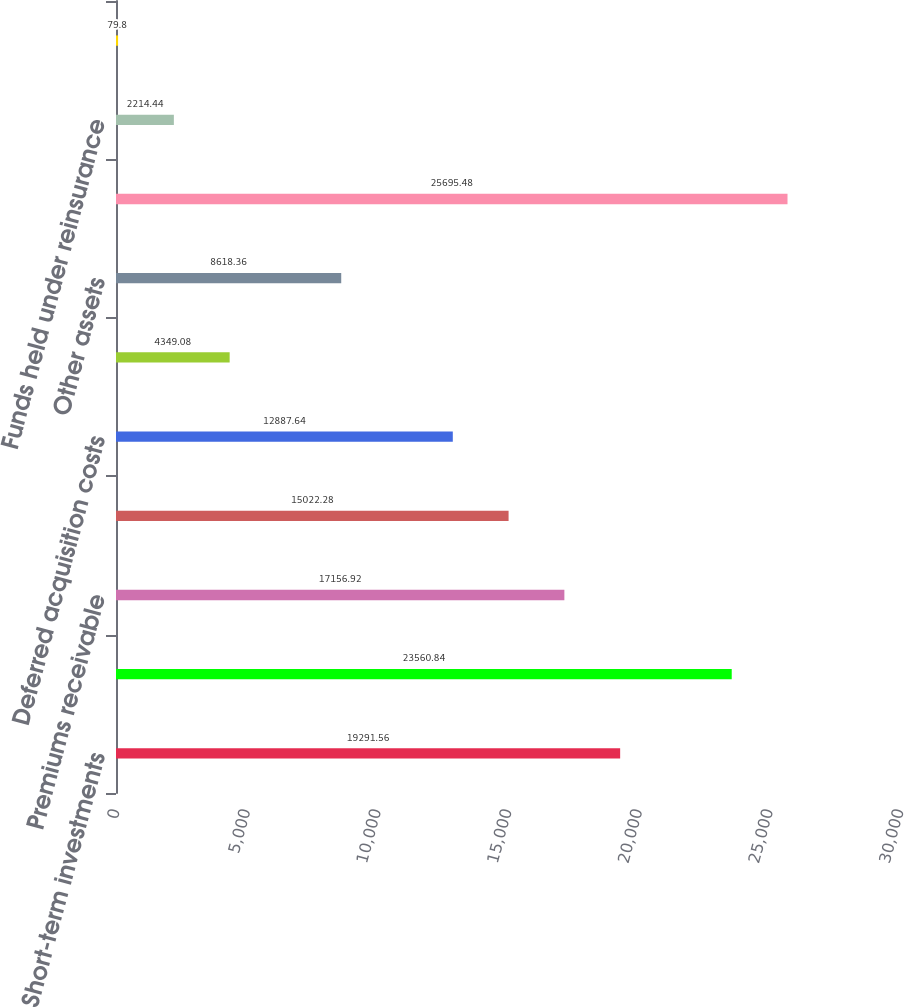<chart> <loc_0><loc_0><loc_500><loc_500><bar_chart><fcel>Short-term investments<fcel>Total investments and cash<fcel>Premiums receivable<fcel>Reinsurance receivables<fcel>Deferred acquisition costs<fcel>Prepaid reinsurance premiums<fcel>Other assets<fcel>TOTAL ASSETS<fcel>Funds held under reinsurance<fcel>Commission reserves<nl><fcel>19291.6<fcel>23560.8<fcel>17156.9<fcel>15022.3<fcel>12887.6<fcel>4349.08<fcel>8618.36<fcel>25695.5<fcel>2214.44<fcel>79.8<nl></chart> 